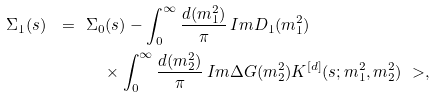<formula> <loc_0><loc_0><loc_500><loc_500>\Sigma _ { 1 } ( s ) \ = \ & \Sigma _ { 0 } ( s ) - \int _ { 0 } ^ { \infty } \frac { d ( m _ { 1 } ^ { 2 } ) } { \pi } \, I m D _ { 1 } ( m _ { 1 } ^ { 2 } ) \\ & \quad \times \int _ { 0 } ^ { \infty } \frac { d ( m _ { 2 } ^ { 2 } ) } { \pi } \, I m \Delta G ( m _ { 2 } ^ { 2 } ) K ^ { [ d ] } ( s ; m _ { 1 } ^ { 2 } , m _ { 2 } ^ { 2 } ) \ > ,</formula> 